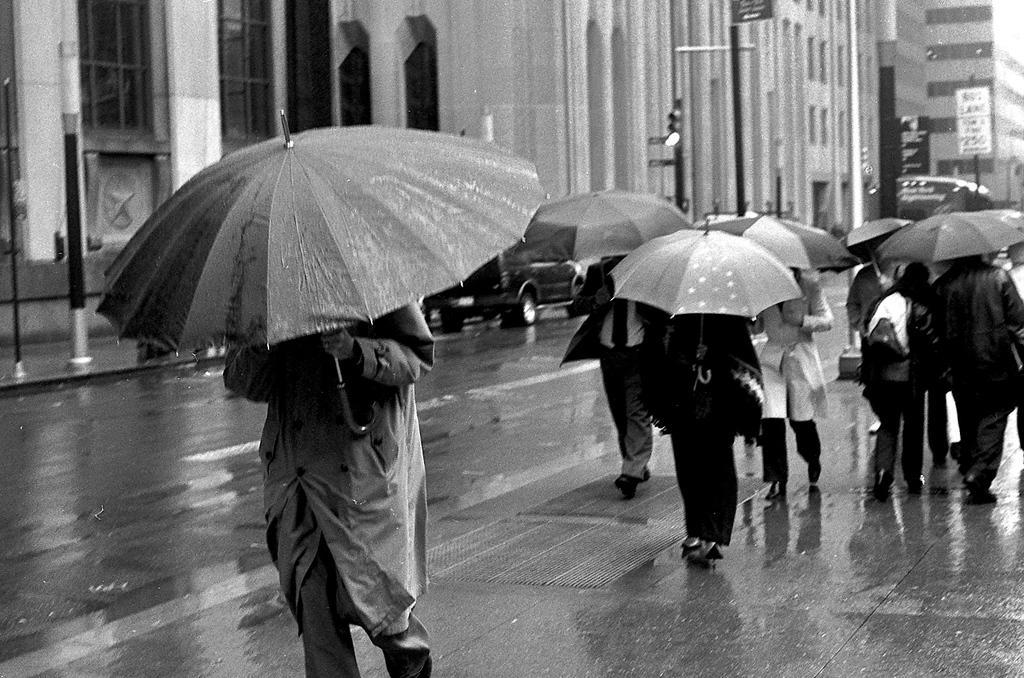Can you describe this image briefly? In this image we can see a black and white image. In this image we can see some persons, umbrellas and other objects. In the background of the image there are buildings, name boards, poles and other objects. At the bottom of the image there is the road. 